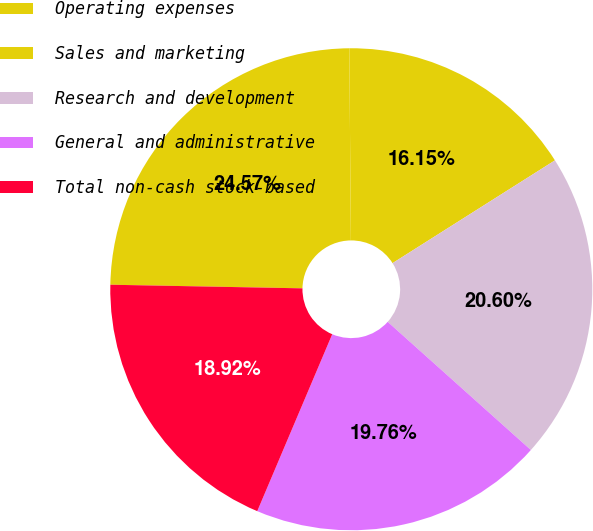<chart> <loc_0><loc_0><loc_500><loc_500><pie_chart><fcel>Operating expenses<fcel>Sales and marketing<fcel>Research and development<fcel>General and administrative<fcel>Total non-cash stock-based<nl><fcel>24.57%<fcel>16.15%<fcel>20.6%<fcel>19.76%<fcel>18.92%<nl></chart> 